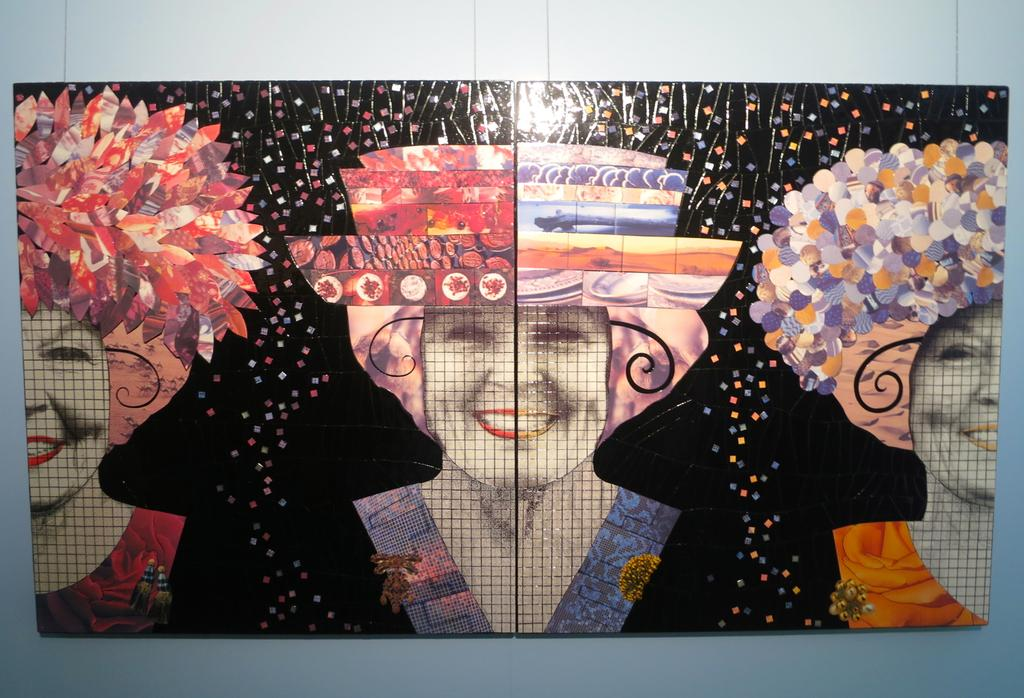How many frames are present in the image? There are two frames in the image. What is depicted in each frame? There are three women's pictures in the frames. What type of stick can be seen in the image? There is no stick present in the image. What time of day is it in the image? The time of day is not mentioned or depicted in the image. 